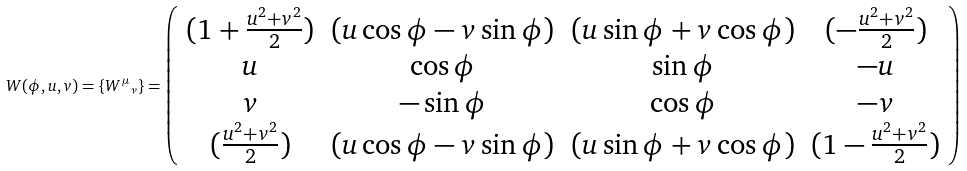Convert formula to latex. <formula><loc_0><loc_0><loc_500><loc_500>W ( \phi , u , v ) = \{ { W ^ { \mu } } _ { \nu } \} = \left ( \begin{array} { c c c c } { { ( 1 + \frac { u ^ { 2 } + v ^ { 2 } } { 2 } ) } } & { ( u \cos \phi - v \sin \phi ) } & { ( u \sin \phi + v \cos \phi ) } & { { ( - \frac { u ^ { 2 } + v ^ { 2 } } { 2 } ) } } \\ { u } & { \cos \phi } & { \sin \phi } & { - u } \\ { v } & { - \sin \phi } & { \cos \phi } & { - v } \\ { { ( \frac { u ^ { 2 } + v ^ { 2 } } { 2 } ) } } & { ( u \cos \phi - v \sin \phi ) } & { ( u \sin \phi + v \cos \phi ) } & { { ( 1 - \frac { u ^ { 2 } + v ^ { 2 } } { 2 } ) } } \end{array} \right )</formula> 